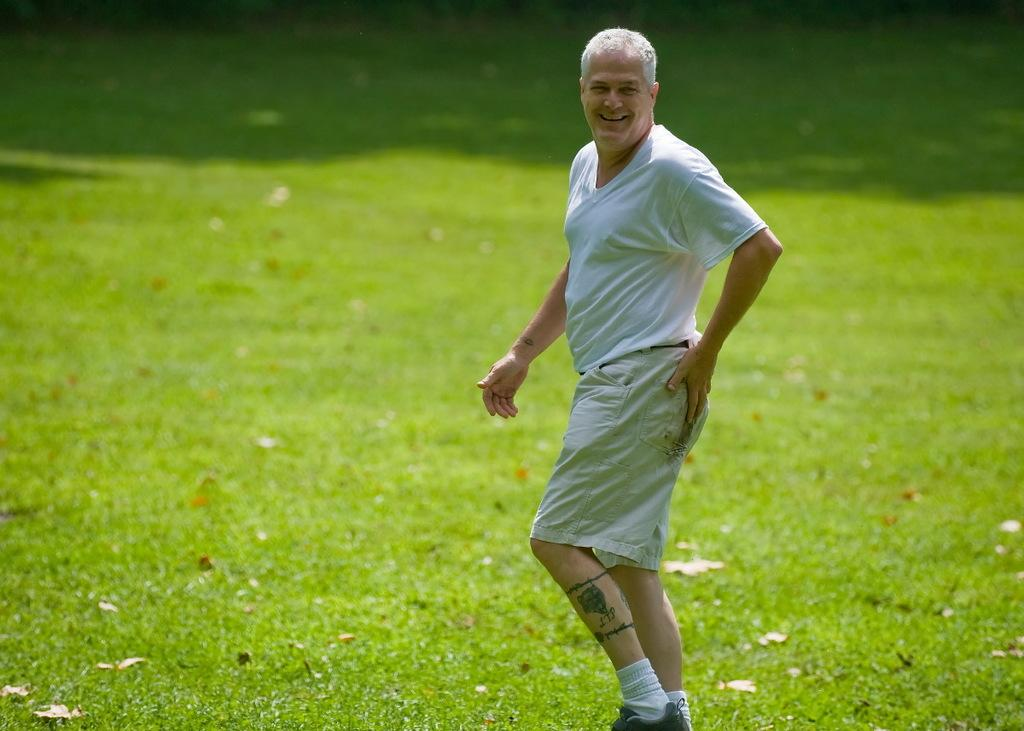What is the main subject of the image? There is a man in the image. What is the man doing in the image? The man is standing in the image. What is the man's facial expression in the image? The man is smiling in the image. What can be seen in the background of the image? There is grass and dried leaves visible in the background of the image. What type of trade is the man engaging in with the horn in the image? There is no mention of trade or a horn in the image. The image only features a man who is standing and smiling, with grass and dried leaves visible in the background. 